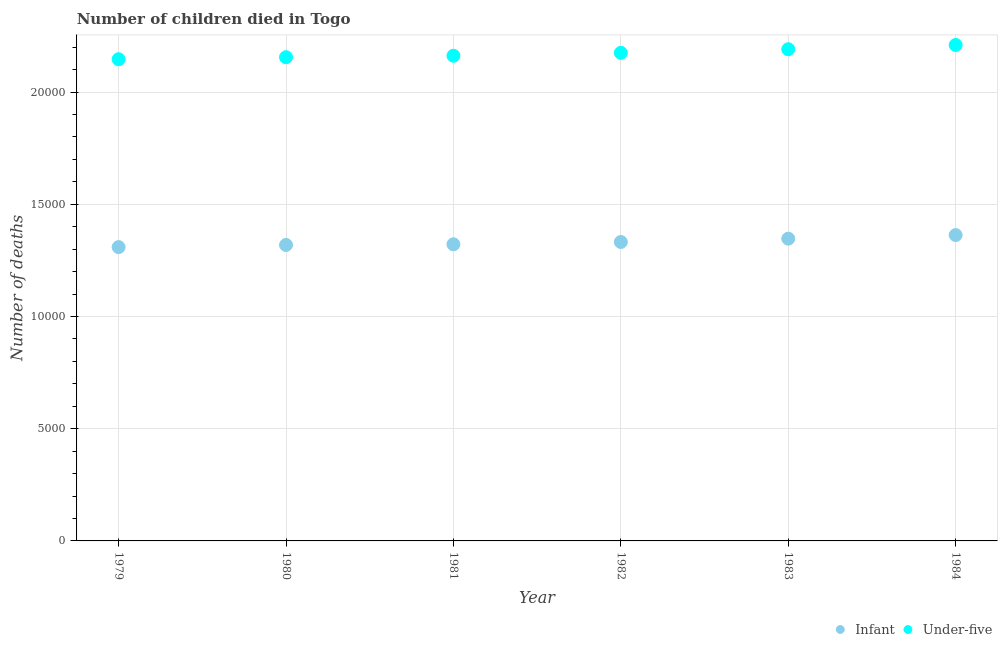What is the number of infant deaths in 1981?
Keep it short and to the point. 1.32e+04. Across all years, what is the maximum number of infant deaths?
Your answer should be very brief. 1.36e+04. Across all years, what is the minimum number of infant deaths?
Provide a succinct answer. 1.31e+04. In which year was the number of infant deaths maximum?
Provide a succinct answer. 1984. In which year was the number of infant deaths minimum?
Your answer should be compact. 1979. What is the total number of infant deaths in the graph?
Provide a succinct answer. 7.99e+04. What is the difference between the number of under-five deaths in 1980 and that in 1981?
Your answer should be very brief. -65. What is the difference between the number of under-five deaths in 1979 and the number of infant deaths in 1983?
Provide a succinct answer. 7995. What is the average number of under-five deaths per year?
Give a very brief answer. 2.17e+04. In the year 1984, what is the difference between the number of infant deaths and number of under-five deaths?
Your answer should be very brief. -8470. What is the ratio of the number of under-five deaths in 1981 to that in 1984?
Your response must be concise. 0.98. What is the difference between the highest and the second highest number of under-five deaths?
Provide a short and direct response. 189. What is the difference between the highest and the lowest number of under-five deaths?
Provide a short and direct response. 635. Is the sum of the number of infant deaths in 1979 and 1980 greater than the maximum number of under-five deaths across all years?
Your response must be concise. Yes. Does the number of under-five deaths monotonically increase over the years?
Ensure brevity in your answer.  Yes. Is the number of under-five deaths strictly less than the number of infant deaths over the years?
Your answer should be very brief. No. How many years are there in the graph?
Your answer should be very brief. 6. What is the difference between two consecutive major ticks on the Y-axis?
Give a very brief answer. 5000. Are the values on the major ticks of Y-axis written in scientific E-notation?
Keep it short and to the point. No. Where does the legend appear in the graph?
Provide a short and direct response. Bottom right. How many legend labels are there?
Provide a succinct answer. 2. What is the title of the graph?
Make the answer very short. Number of children died in Togo. Does "Age 65(male)" appear as one of the legend labels in the graph?
Give a very brief answer. No. What is the label or title of the X-axis?
Give a very brief answer. Year. What is the label or title of the Y-axis?
Your answer should be very brief. Number of deaths. What is the Number of deaths in Infant in 1979?
Give a very brief answer. 1.31e+04. What is the Number of deaths in Under-five in 1979?
Offer a terse response. 2.15e+04. What is the Number of deaths of Infant in 1980?
Your answer should be compact. 1.32e+04. What is the Number of deaths in Under-five in 1980?
Your answer should be compact. 2.16e+04. What is the Number of deaths in Infant in 1981?
Offer a very short reply. 1.32e+04. What is the Number of deaths of Under-five in 1981?
Offer a very short reply. 2.16e+04. What is the Number of deaths of Infant in 1982?
Give a very brief answer. 1.33e+04. What is the Number of deaths of Under-five in 1982?
Provide a short and direct response. 2.17e+04. What is the Number of deaths in Infant in 1983?
Your answer should be very brief. 1.35e+04. What is the Number of deaths in Under-five in 1983?
Offer a terse response. 2.19e+04. What is the Number of deaths in Infant in 1984?
Your response must be concise. 1.36e+04. What is the Number of deaths of Under-five in 1984?
Offer a terse response. 2.21e+04. Across all years, what is the maximum Number of deaths in Infant?
Offer a terse response. 1.36e+04. Across all years, what is the maximum Number of deaths in Under-five?
Offer a terse response. 2.21e+04. Across all years, what is the minimum Number of deaths of Infant?
Your answer should be compact. 1.31e+04. Across all years, what is the minimum Number of deaths in Under-five?
Offer a very short reply. 2.15e+04. What is the total Number of deaths of Infant in the graph?
Provide a succinct answer. 7.99e+04. What is the total Number of deaths in Under-five in the graph?
Provide a succinct answer. 1.30e+05. What is the difference between the Number of deaths in Infant in 1979 and that in 1980?
Make the answer very short. -96. What is the difference between the Number of deaths of Under-five in 1979 and that in 1980?
Keep it short and to the point. -90. What is the difference between the Number of deaths in Infant in 1979 and that in 1981?
Offer a very short reply. -126. What is the difference between the Number of deaths of Under-five in 1979 and that in 1981?
Provide a short and direct response. -155. What is the difference between the Number of deaths in Infant in 1979 and that in 1982?
Make the answer very short. -229. What is the difference between the Number of deaths in Under-five in 1979 and that in 1982?
Make the answer very short. -285. What is the difference between the Number of deaths in Infant in 1979 and that in 1983?
Your answer should be very brief. -377. What is the difference between the Number of deaths in Under-five in 1979 and that in 1983?
Give a very brief answer. -446. What is the difference between the Number of deaths of Infant in 1979 and that in 1984?
Your answer should be very brief. -537. What is the difference between the Number of deaths in Under-five in 1979 and that in 1984?
Offer a very short reply. -635. What is the difference between the Number of deaths of Under-five in 1980 and that in 1981?
Your answer should be very brief. -65. What is the difference between the Number of deaths in Infant in 1980 and that in 1982?
Keep it short and to the point. -133. What is the difference between the Number of deaths of Under-five in 1980 and that in 1982?
Provide a succinct answer. -195. What is the difference between the Number of deaths in Infant in 1980 and that in 1983?
Offer a terse response. -281. What is the difference between the Number of deaths of Under-five in 1980 and that in 1983?
Provide a succinct answer. -356. What is the difference between the Number of deaths of Infant in 1980 and that in 1984?
Provide a short and direct response. -441. What is the difference between the Number of deaths in Under-five in 1980 and that in 1984?
Your answer should be compact. -545. What is the difference between the Number of deaths in Infant in 1981 and that in 1982?
Your answer should be very brief. -103. What is the difference between the Number of deaths of Under-five in 1981 and that in 1982?
Make the answer very short. -130. What is the difference between the Number of deaths of Infant in 1981 and that in 1983?
Keep it short and to the point. -251. What is the difference between the Number of deaths in Under-five in 1981 and that in 1983?
Your response must be concise. -291. What is the difference between the Number of deaths of Infant in 1981 and that in 1984?
Provide a short and direct response. -411. What is the difference between the Number of deaths of Under-five in 1981 and that in 1984?
Offer a very short reply. -480. What is the difference between the Number of deaths of Infant in 1982 and that in 1983?
Your response must be concise. -148. What is the difference between the Number of deaths of Under-five in 1982 and that in 1983?
Provide a succinct answer. -161. What is the difference between the Number of deaths in Infant in 1982 and that in 1984?
Your response must be concise. -308. What is the difference between the Number of deaths of Under-five in 1982 and that in 1984?
Keep it short and to the point. -350. What is the difference between the Number of deaths of Infant in 1983 and that in 1984?
Offer a very short reply. -160. What is the difference between the Number of deaths in Under-five in 1983 and that in 1984?
Your answer should be very brief. -189. What is the difference between the Number of deaths of Infant in 1979 and the Number of deaths of Under-five in 1980?
Ensure brevity in your answer.  -8462. What is the difference between the Number of deaths of Infant in 1979 and the Number of deaths of Under-five in 1981?
Provide a succinct answer. -8527. What is the difference between the Number of deaths in Infant in 1979 and the Number of deaths in Under-five in 1982?
Give a very brief answer. -8657. What is the difference between the Number of deaths in Infant in 1979 and the Number of deaths in Under-five in 1983?
Make the answer very short. -8818. What is the difference between the Number of deaths in Infant in 1979 and the Number of deaths in Under-five in 1984?
Your response must be concise. -9007. What is the difference between the Number of deaths in Infant in 1980 and the Number of deaths in Under-five in 1981?
Ensure brevity in your answer.  -8431. What is the difference between the Number of deaths in Infant in 1980 and the Number of deaths in Under-five in 1982?
Your answer should be very brief. -8561. What is the difference between the Number of deaths in Infant in 1980 and the Number of deaths in Under-five in 1983?
Your answer should be compact. -8722. What is the difference between the Number of deaths in Infant in 1980 and the Number of deaths in Under-five in 1984?
Make the answer very short. -8911. What is the difference between the Number of deaths in Infant in 1981 and the Number of deaths in Under-five in 1982?
Provide a succinct answer. -8531. What is the difference between the Number of deaths of Infant in 1981 and the Number of deaths of Under-five in 1983?
Offer a very short reply. -8692. What is the difference between the Number of deaths of Infant in 1981 and the Number of deaths of Under-five in 1984?
Your answer should be compact. -8881. What is the difference between the Number of deaths in Infant in 1982 and the Number of deaths in Under-five in 1983?
Make the answer very short. -8589. What is the difference between the Number of deaths in Infant in 1982 and the Number of deaths in Under-five in 1984?
Offer a very short reply. -8778. What is the difference between the Number of deaths of Infant in 1983 and the Number of deaths of Under-five in 1984?
Offer a terse response. -8630. What is the average Number of deaths of Infant per year?
Offer a terse response. 1.33e+04. What is the average Number of deaths of Under-five per year?
Ensure brevity in your answer.  2.17e+04. In the year 1979, what is the difference between the Number of deaths of Infant and Number of deaths of Under-five?
Provide a short and direct response. -8372. In the year 1980, what is the difference between the Number of deaths of Infant and Number of deaths of Under-five?
Provide a short and direct response. -8366. In the year 1981, what is the difference between the Number of deaths of Infant and Number of deaths of Under-five?
Provide a succinct answer. -8401. In the year 1982, what is the difference between the Number of deaths of Infant and Number of deaths of Under-five?
Ensure brevity in your answer.  -8428. In the year 1983, what is the difference between the Number of deaths of Infant and Number of deaths of Under-five?
Provide a succinct answer. -8441. In the year 1984, what is the difference between the Number of deaths in Infant and Number of deaths in Under-five?
Your response must be concise. -8470. What is the ratio of the Number of deaths of Infant in 1979 to that in 1980?
Provide a succinct answer. 0.99. What is the ratio of the Number of deaths in Infant in 1979 to that in 1981?
Ensure brevity in your answer.  0.99. What is the ratio of the Number of deaths in Under-five in 1979 to that in 1981?
Your answer should be compact. 0.99. What is the ratio of the Number of deaths in Infant in 1979 to that in 1982?
Keep it short and to the point. 0.98. What is the ratio of the Number of deaths of Under-five in 1979 to that in 1982?
Offer a very short reply. 0.99. What is the ratio of the Number of deaths of Under-five in 1979 to that in 1983?
Your response must be concise. 0.98. What is the ratio of the Number of deaths of Infant in 1979 to that in 1984?
Your answer should be very brief. 0.96. What is the ratio of the Number of deaths of Under-five in 1979 to that in 1984?
Your response must be concise. 0.97. What is the ratio of the Number of deaths of Infant in 1980 to that in 1982?
Your answer should be very brief. 0.99. What is the ratio of the Number of deaths of Under-five in 1980 to that in 1982?
Your answer should be compact. 0.99. What is the ratio of the Number of deaths of Infant in 1980 to that in 1983?
Your answer should be very brief. 0.98. What is the ratio of the Number of deaths in Under-five in 1980 to that in 1983?
Your answer should be compact. 0.98. What is the ratio of the Number of deaths in Infant in 1980 to that in 1984?
Offer a terse response. 0.97. What is the ratio of the Number of deaths in Under-five in 1980 to that in 1984?
Offer a very short reply. 0.98. What is the ratio of the Number of deaths of Under-five in 1981 to that in 1982?
Give a very brief answer. 0.99. What is the ratio of the Number of deaths of Infant in 1981 to that in 1983?
Offer a terse response. 0.98. What is the ratio of the Number of deaths in Under-five in 1981 to that in 1983?
Your response must be concise. 0.99. What is the ratio of the Number of deaths in Infant in 1981 to that in 1984?
Your answer should be compact. 0.97. What is the ratio of the Number of deaths in Under-five in 1981 to that in 1984?
Your answer should be very brief. 0.98. What is the ratio of the Number of deaths of Infant in 1982 to that in 1984?
Your answer should be compact. 0.98. What is the ratio of the Number of deaths in Under-five in 1982 to that in 1984?
Make the answer very short. 0.98. What is the ratio of the Number of deaths of Infant in 1983 to that in 1984?
Make the answer very short. 0.99. What is the ratio of the Number of deaths in Under-five in 1983 to that in 1984?
Offer a terse response. 0.99. What is the difference between the highest and the second highest Number of deaths of Infant?
Offer a terse response. 160. What is the difference between the highest and the second highest Number of deaths in Under-five?
Give a very brief answer. 189. What is the difference between the highest and the lowest Number of deaths of Infant?
Make the answer very short. 537. What is the difference between the highest and the lowest Number of deaths of Under-five?
Give a very brief answer. 635. 